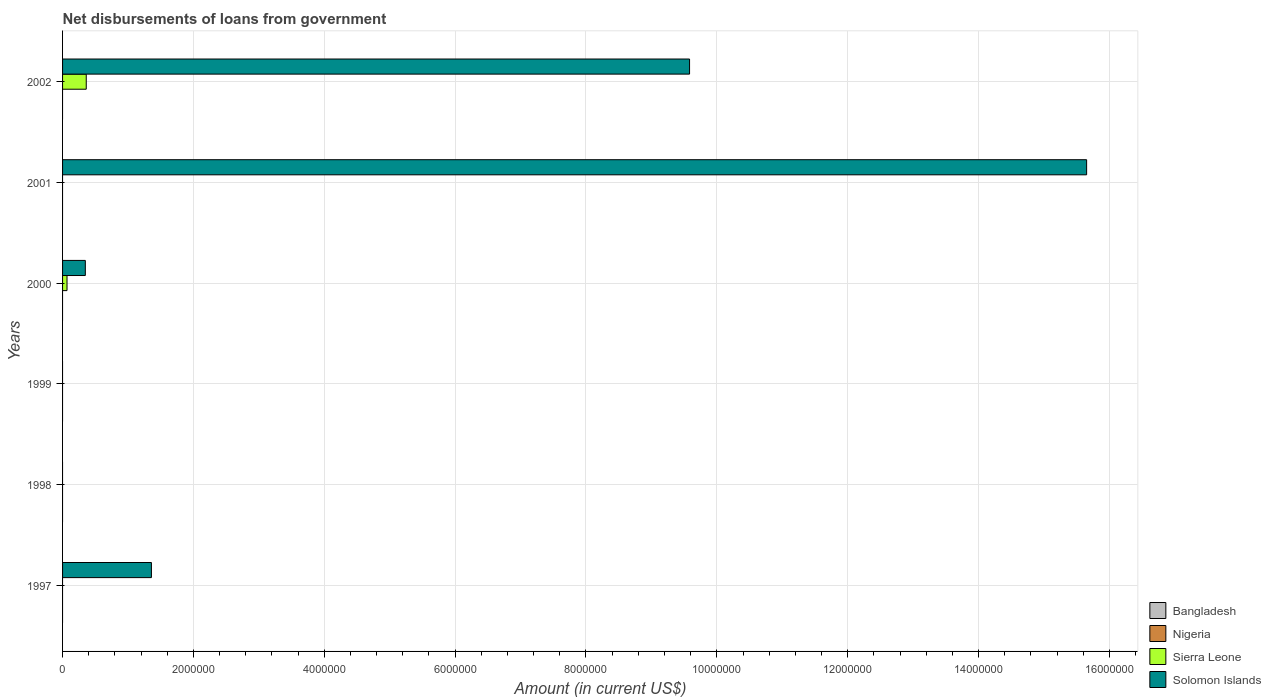How many different coloured bars are there?
Give a very brief answer. 2. How many bars are there on the 3rd tick from the top?
Your answer should be compact. 2. What is the label of the 5th group of bars from the top?
Ensure brevity in your answer.  1998. What is the amount of loan disbursed from government in Sierra Leone in 1998?
Provide a short and direct response. 0. Across all years, what is the maximum amount of loan disbursed from government in Sierra Leone?
Your answer should be compact. 3.62e+05. Across all years, what is the minimum amount of loan disbursed from government in Bangladesh?
Ensure brevity in your answer.  0. In which year was the amount of loan disbursed from government in Solomon Islands maximum?
Provide a succinct answer. 2001. What is the total amount of loan disbursed from government in Solomon Islands in the graph?
Give a very brief answer. 2.69e+07. What is the difference between the amount of loan disbursed from government in Solomon Islands in 2001 and that in 2002?
Your answer should be very brief. 6.07e+06. What is the ratio of the amount of loan disbursed from government in Solomon Islands in 2001 to that in 2002?
Your response must be concise. 1.63. What is the difference between the highest and the second highest amount of loan disbursed from government in Solomon Islands?
Offer a terse response. 6.07e+06. What is the difference between the highest and the lowest amount of loan disbursed from government in Solomon Islands?
Make the answer very short. 1.57e+07. In how many years, is the amount of loan disbursed from government in Solomon Islands greater than the average amount of loan disbursed from government in Solomon Islands taken over all years?
Provide a short and direct response. 2. What is the difference between two consecutive major ticks on the X-axis?
Offer a terse response. 2.00e+06. Does the graph contain any zero values?
Ensure brevity in your answer.  Yes. Does the graph contain grids?
Provide a short and direct response. Yes. How are the legend labels stacked?
Your answer should be very brief. Vertical. What is the title of the graph?
Your response must be concise. Net disbursements of loans from government. What is the label or title of the X-axis?
Your answer should be compact. Amount (in current US$). What is the Amount (in current US$) of Bangladesh in 1997?
Offer a terse response. 0. What is the Amount (in current US$) in Sierra Leone in 1997?
Provide a short and direct response. 0. What is the Amount (in current US$) of Solomon Islands in 1997?
Your answer should be compact. 1.36e+06. What is the Amount (in current US$) of Bangladesh in 1998?
Your answer should be compact. 0. What is the Amount (in current US$) of Nigeria in 1998?
Ensure brevity in your answer.  0. What is the Amount (in current US$) in Sierra Leone in 1998?
Keep it short and to the point. 0. What is the Amount (in current US$) of Nigeria in 1999?
Give a very brief answer. 0. What is the Amount (in current US$) of Bangladesh in 2000?
Make the answer very short. 0. What is the Amount (in current US$) in Sierra Leone in 2000?
Offer a very short reply. 6.80e+04. What is the Amount (in current US$) in Solomon Islands in 2000?
Your answer should be very brief. 3.48e+05. What is the Amount (in current US$) in Nigeria in 2001?
Give a very brief answer. 0. What is the Amount (in current US$) in Solomon Islands in 2001?
Your answer should be very brief. 1.57e+07. What is the Amount (in current US$) in Bangladesh in 2002?
Your answer should be very brief. 0. What is the Amount (in current US$) of Nigeria in 2002?
Ensure brevity in your answer.  0. What is the Amount (in current US$) of Sierra Leone in 2002?
Give a very brief answer. 3.62e+05. What is the Amount (in current US$) of Solomon Islands in 2002?
Offer a very short reply. 9.58e+06. Across all years, what is the maximum Amount (in current US$) in Sierra Leone?
Ensure brevity in your answer.  3.62e+05. Across all years, what is the maximum Amount (in current US$) in Solomon Islands?
Your response must be concise. 1.57e+07. Across all years, what is the minimum Amount (in current US$) in Solomon Islands?
Offer a very short reply. 0. What is the total Amount (in current US$) in Bangladesh in the graph?
Make the answer very short. 0. What is the total Amount (in current US$) in Sierra Leone in the graph?
Keep it short and to the point. 4.30e+05. What is the total Amount (in current US$) in Solomon Islands in the graph?
Your response must be concise. 2.69e+07. What is the difference between the Amount (in current US$) in Solomon Islands in 1997 and that in 2000?
Provide a succinct answer. 1.01e+06. What is the difference between the Amount (in current US$) of Solomon Islands in 1997 and that in 2001?
Provide a succinct answer. -1.43e+07. What is the difference between the Amount (in current US$) in Solomon Islands in 1997 and that in 2002?
Keep it short and to the point. -8.22e+06. What is the difference between the Amount (in current US$) of Solomon Islands in 2000 and that in 2001?
Provide a succinct answer. -1.53e+07. What is the difference between the Amount (in current US$) in Sierra Leone in 2000 and that in 2002?
Your response must be concise. -2.94e+05. What is the difference between the Amount (in current US$) of Solomon Islands in 2000 and that in 2002?
Provide a succinct answer. -9.24e+06. What is the difference between the Amount (in current US$) in Solomon Islands in 2001 and that in 2002?
Your answer should be compact. 6.07e+06. What is the difference between the Amount (in current US$) in Sierra Leone in 2000 and the Amount (in current US$) in Solomon Islands in 2001?
Your answer should be very brief. -1.56e+07. What is the difference between the Amount (in current US$) in Sierra Leone in 2000 and the Amount (in current US$) in Solomon Islands in 2002?
Keep it short and to the point. -9.52e+06. What is the average Amount (in current US$) in Sierra Leone per year?
Offer a very short reply. 7.17e+04. What is the average Amount (in current US$) in Solomon Islands per year?
Offer a very short reply. 4.49e+06. In the year 2000, what is the difference between the Amount (in current US$) in Sierra Leone and Amount (in current US$) in Solomon Islands?
Provide a succinct answer. -2.80e+05. In the year 2002, what is the difference between the Amount (in current US$) of Sierra Leone and Amount (in current US$) of Solomon Islands?
Make the answer very short. -9.22e+06. What is the ratio of the Amount (in current US$) of Solomon Islands in 1997 to that in 2000?
Your response must be concise. 3.9. What is the ratio of the Amount (in current US$) in Solomon Islands in 1997 to that in 2001?
Provide a short and direct response. 0.09. What is the ratio of the Amount (in current US$) of Solomon Islands in 1997 to that in 2002?
Give a very brief answer. 0.14. What is the ratio of the Amount (in current US$) of Solomon Islands in 2000 to that in 2001?
Ensure brevity in your answer.  0.02. What is the ratio of the Amount (in current US$) of Sierra Leone in 2000 to that in 2002?
Make the answer very short. 0.19. What is the ratio of the Amount (in current US$) in Solomon Islands in 2000 to that in 2002?
Offer a very short reply. 0.04. What is the ratio of the Amount (in current US$) in Solomon Islands in 2001 to that in 2002?
Your answer should be compact. 1.63. What is the difference between the highest and the second highest Amount (in current US$) of Solomon Islands?
Your answer should be compact. 6.07e+06. What is the difference between the highest and the lowest Amount (in current US$) of Sierra Leone?
Your answer should be very brief. 3.62e+05. What is the difference between the highest and the lowest Amount (in current US$) in Solomon Islands?
Offer a terse response. 1.57e+07. 